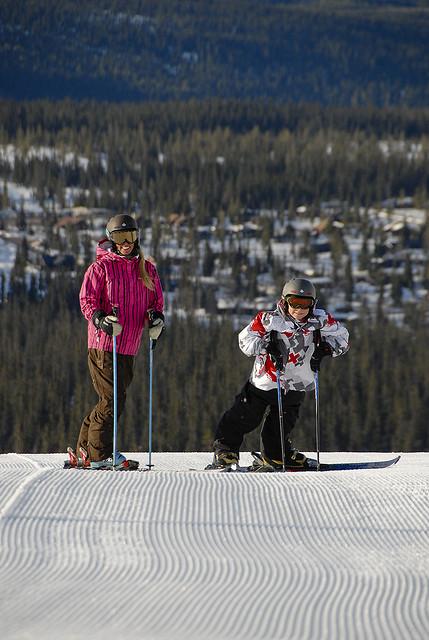Are they taking a break?
Short answer required. Yes. Are both people wearing skis?
Give a very brief answer. Yes. Why are there lines on the ground?
Be succinct. Skis. 